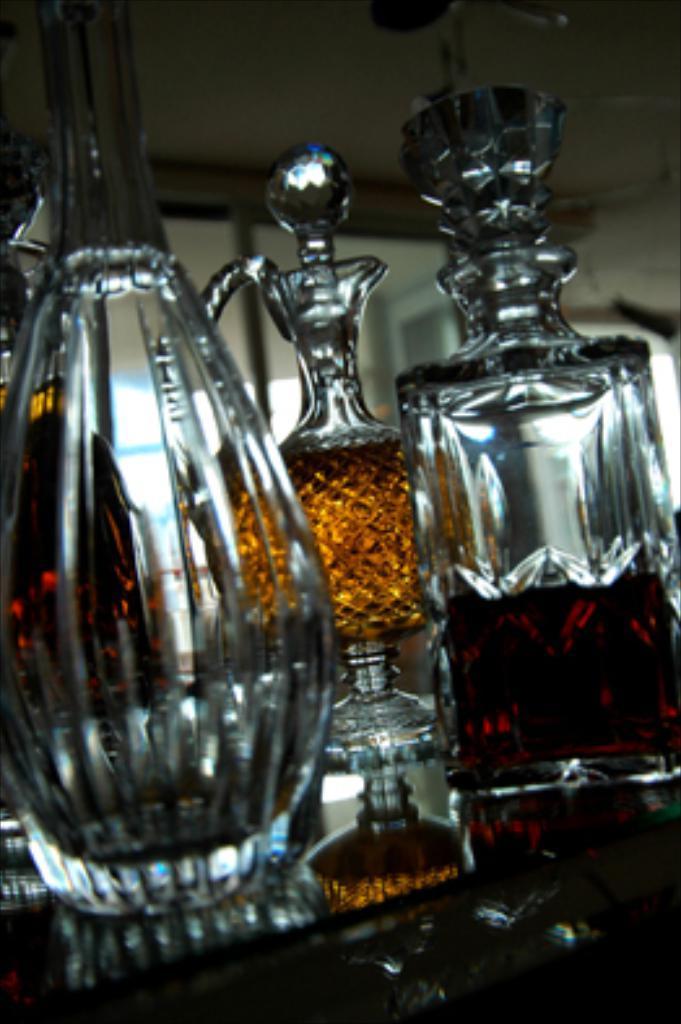Please provide a concise description of this image. there are glass bottles. the bottles at the back are filled with liquid. 